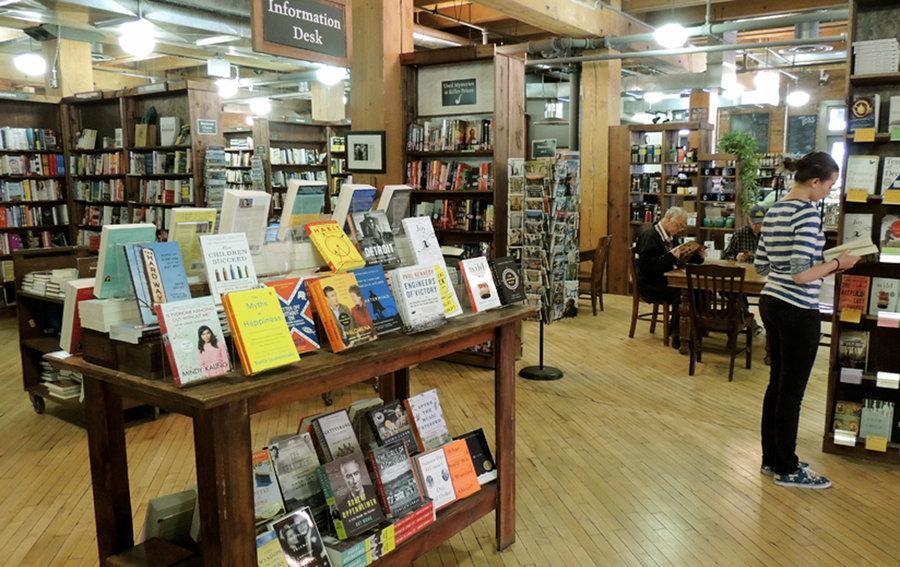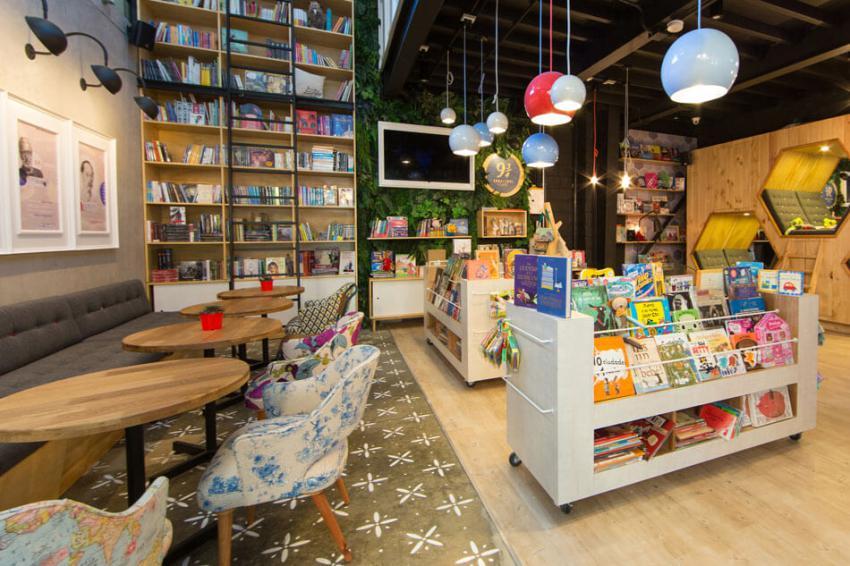The first image is the image on the left, the second image is the image on the right. Evaluate the accuracy of this statement regarding the images: "There are no more than 4 people in the image on the right.". Is it true? Answer yes or no. No. 